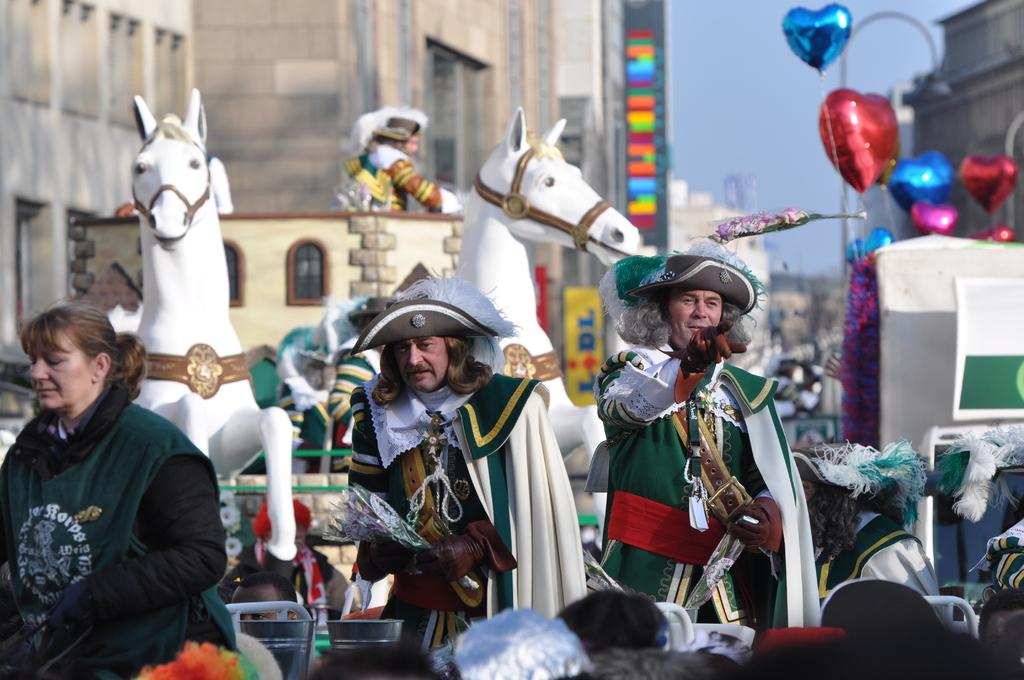Who or what can be seen in the image? There are people, balloons, and horses in the image. What else is present in the image besides the people, balloons, and horses? There are buildings in the background of the image. What can be seen in the sky in the image? The sky is visible in the background of the image. What type of coastline can be seen in the image? There is no coastline present in the image; it features people, balloons, horses, buildings, and the sky. How many toes are visible on the horses in the image? Horses do not have toes; they have hooves, and none are visible in the image. 